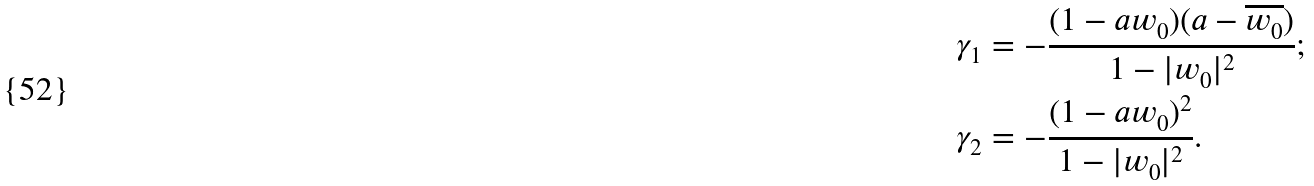<formula> <loc_0><loc_0><loc_500><loc_500>\gamma _ { 1 } & = - \frac { ( 1 - a w _ { 0 } ) ( a - \overline { w _ { 0 } } ) } { 1 - | w _ { 0 } | ^ { 2 } } ; \\ \gamma _ { 2 } & = - \frac { ( 1 - a w _ { 0 } ) ^ { 2 } } { 1 - | w _ { 0 } | ^ { 2 } } .</formula> 